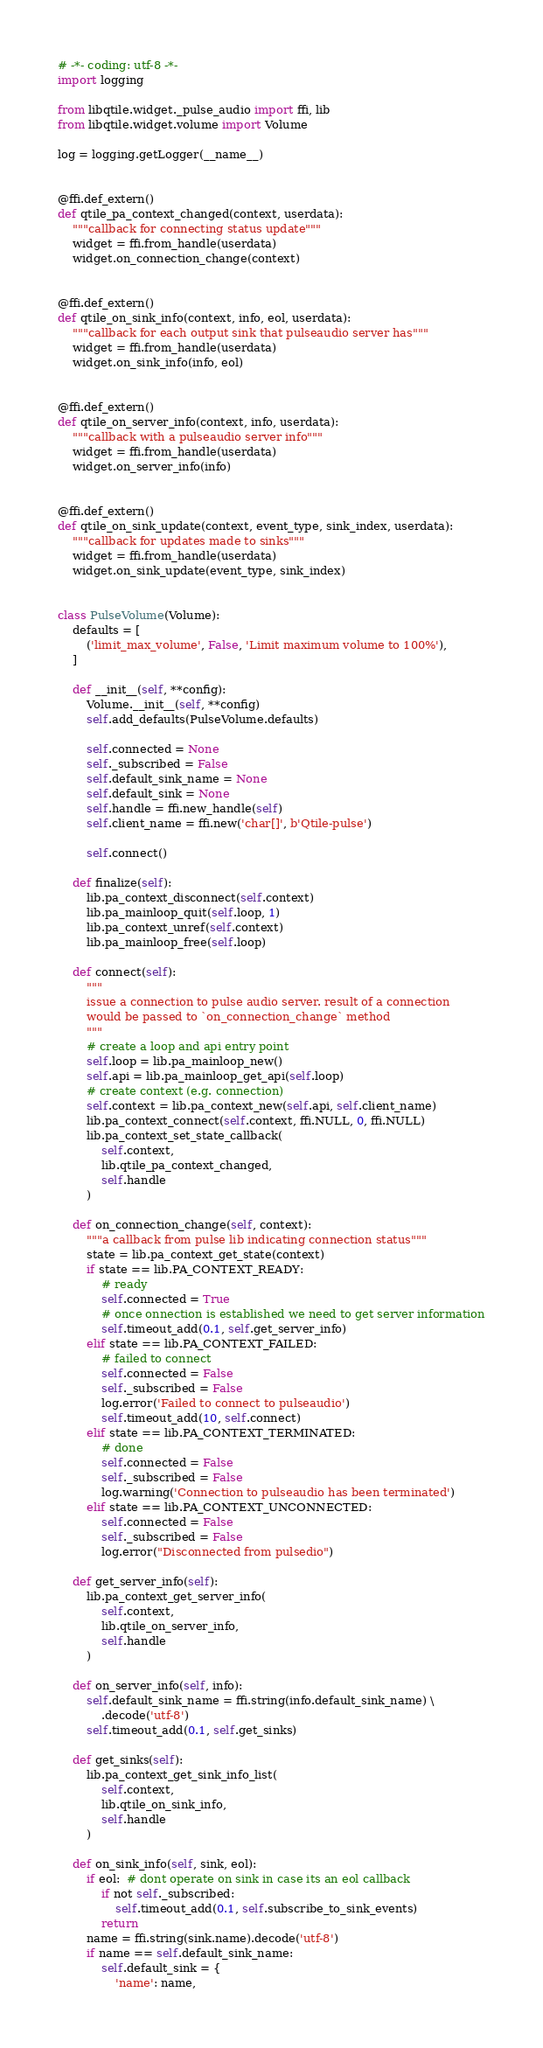Convert code to text. <code><loc_0><loc_0><loc_500><loc_500><_Python_># -*- coding: utf-8 -*-
import logging

from libqtile.widget._pulse_audio import ffi, lib
from libqtile.widget.volume import Volume

log = logging.getLogger(__name__)


@ffi.def_extern()
def qtile_pa_context_changed(context, userdata):
    """callback for connecting status update"""
    widget = ffi.from_handle(userdata)
    widget.on_connection_change(context)


@ffi.def_extern()
def qtile_on_sink_info(context, info, eol, userdata):
    """callback for each output sink that pulseaudio server has"""
    widget = ffi.from_handle(userdata)
    widget.on_sink_info(info, eol)


@ffi.def_extern()
def qtile_on_server_info(context, info, userdata):
    """callback with a pulseaudio server info"""
    widget = ffi.from_handle(userdata)
    widget.on_server_info(info)


@ffi.def_extern()
def qtile_on_sink_update(context, event_type, sink_index, userdata):
    """callback for updates made to sinks"""
    widget = ffi.from_handle(userdata)
    widget.on_sink_update(event_type, sink_index)


class PulseVolume(Volume):
    defaults = [
        ('limit_max_volume', False, 'Limit maximum volume to 100%'),
    ]

    def __init__(self, **config):
        Volume.__init__(self, **config)
        self.add_defaults(PulseVolume.defaults)

        self.connected = None
        self._subscribed = False
        self.default_sink_name = None
        self.default_sink = None
        self.handle = ffi.new_handle(self)
        self.client_name = ffi.new('char[]', b'Qtile-pulse')

        self.connect()

    def finalize(self):
        lib.pa_context_disconnect(self.context)
        lib.pa_mainloop_quit(self.loop, 1)
        lib.pa_context_unref(self.context)
        lib.pa_mainloop_free(self.loop)

    def connect(self):
        """
        issue a connection to pulse audio server. result of a connection
        would be passed to `on_connection_change` method
        """
        # create a loop and api entry point
        self.loop = lib.pa_mainloop_new()
        self.api = lib.pa_mainloop_get_api(self.loop)
        # create context (e.g. connection)
        self.context = lib.pa_context_new(self.api, self.client_name)
        lib.pa_context_connect(self.context, ffi.NULL, 0, ffi.NULL)
        lib.pa_context_set_state_callback(
            self.context,
            lib.qtile_pa_context_changed,
            self.handle
        )

    def on_connection_change(self, context):
        """a callback from pulse lib indicating connection status"""
        state = lib.pa_context_get_state(context)
        if state == lib.PA_CONTEXT_READY:
            # ready
            self.connected = True
            # once onnection is established we need to get server information
            self.timeout_add(0.1, self.get_server_info)
        elif state == lib.PA_CONTEXT_FAILED:
            # failed to connect
            self.connected = False
            self._subscribed = False
            log.error('Failed to connect to pulseaudio')
            self.timeout_add(10, self.connect)
        elif state == lib.PA_CONTEXT_TERMINATED:
            # done
            self.connected = False
            self._subscribed = False
            log.warning('Connection to pulseaudio has been terminated')
        elif state == lib.PA_CONTEXT_UNCONNECTED:
            self.connected = False
            self._subscribed = False
            log.error("Disconnected from pulsedio")

    def get_server_info(self):
        lib.pa_context_get_server_info(
            self.context,
            lib.qtile_on_server_info,
            self.handle
        )

    def on_server_info(self, info):
        self.default_sink_name = ffi.string(info.default_sink_name) \
            .decode('utf-8')
        self.timeout_add(0.1, self.get_sinks)

    def get_sinks(self):
        lib.pa_context_get_sink_info_list(
            self.context,
            lib.qtile_on_sink_info,
            self.handle
        )

    def on_sink_info(self, sink, eol):
        if eol:  # dont operate on sink in case its an eol callback
            if not self._subscribed:
                self.timeout_add(0.1, self.subscribe_to_sink_events)
            return
        name = ffi.string(sink.name).decode('utf-8')
        if name == self.default_sink_name:
            self.default_sink = {
                'name': name,</code> 